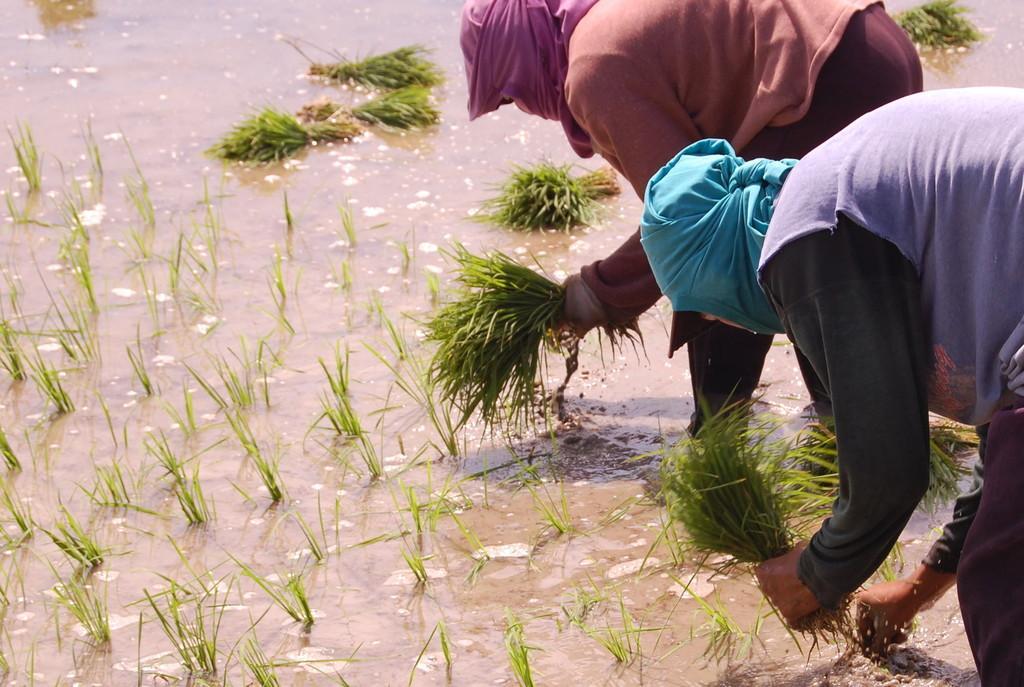In one or two sentences, can you explain what this image depicts? In the picture I can see two persons are bending and holding the grass in hands. Here I can see the water and the grass. These people has covered their faces with clothes. 